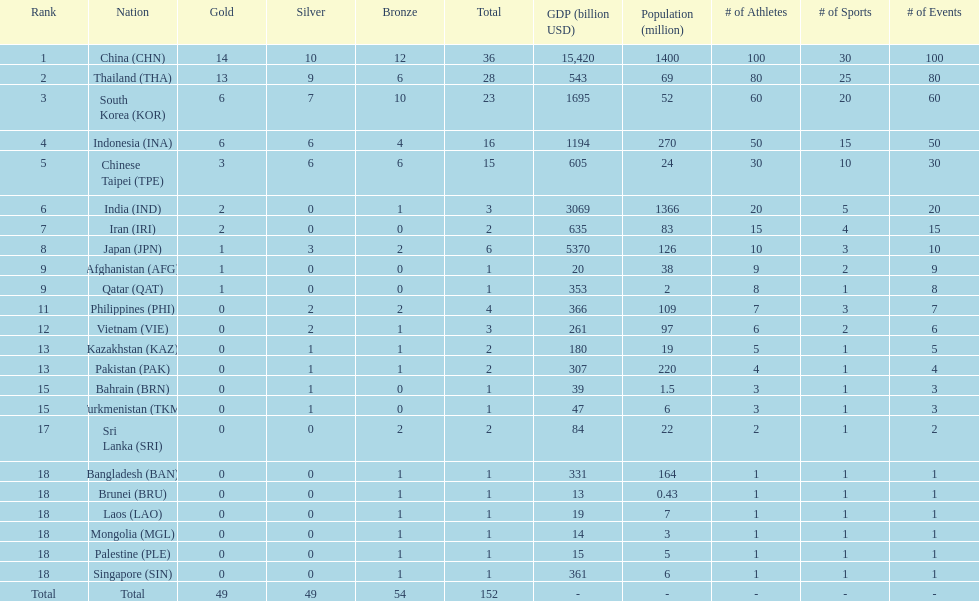Which countries won the same number of gold medals as japan? Afghanistan (AFG), Qatar (QAT). 